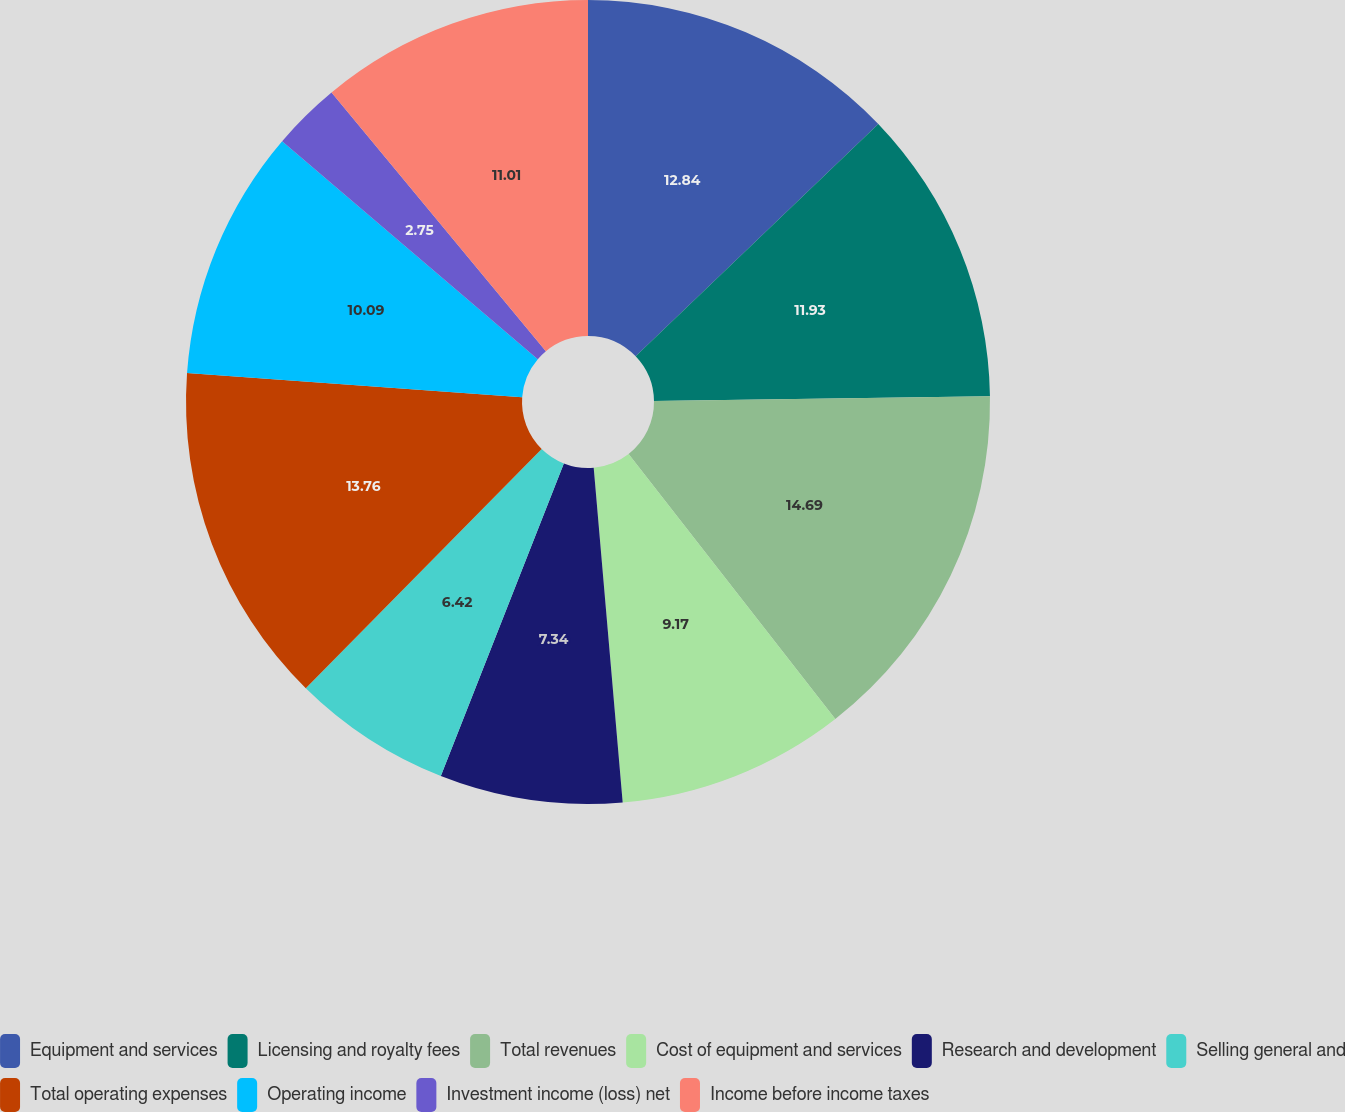Convert chart to OTSL. <chart><loc_0><loc_0><loc_500><loc_500><pie_chart><fcel>Equipment and services<fcel>Licensing and royalty fees<fcel>Total revenues<fcel>Cost of equipment and services<fcel>Research and development<fcel>Selling general and<fcel>Total operating expenses<fcel>Operating income<fcel>Investment income (loss) net<fcel>Income before income taxes<nl><fcel>12.84%<fcel>11.93%<fcel>14.68%<fcel>9.17%<fcel>7.34%<fcel>6.42%<fcel>13.76%<fcel>10.09%<fcel>2.75%<fcel>11.01%<nl></chart> 